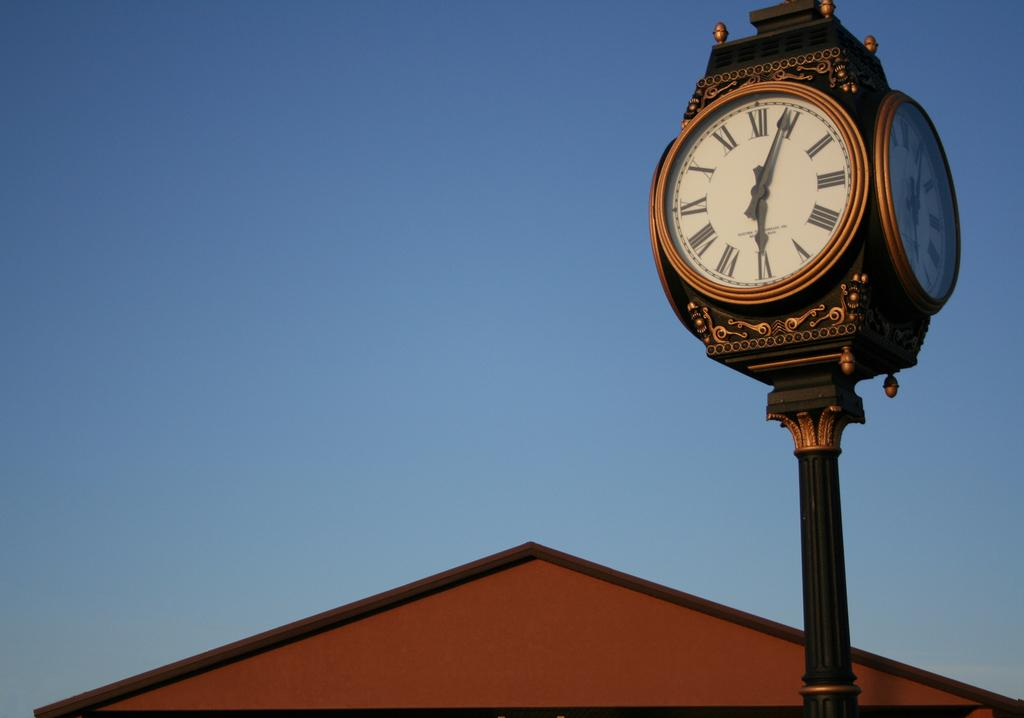<image>
Describe the image concisely. An antique clock tower shows the time four past six. 